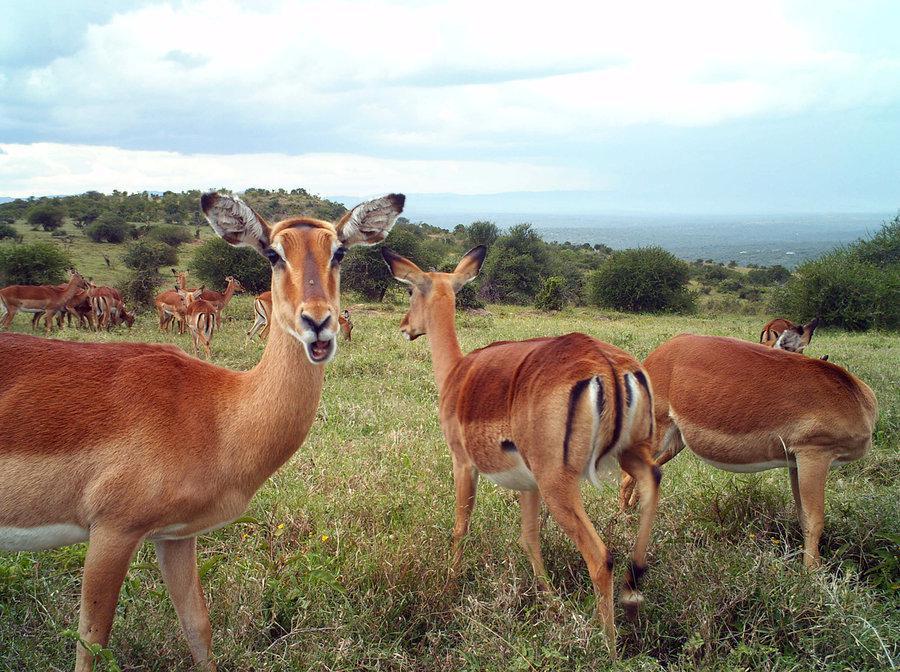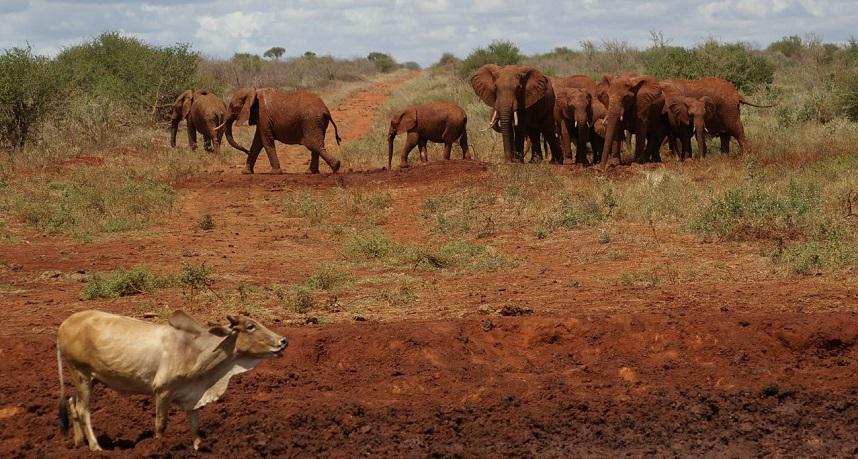The first image is the image on the left, the second image is the image on the right. For the images displayed, is the sentence "Each image has one animal that has horns." factually correct? Answer yes or no. No. 